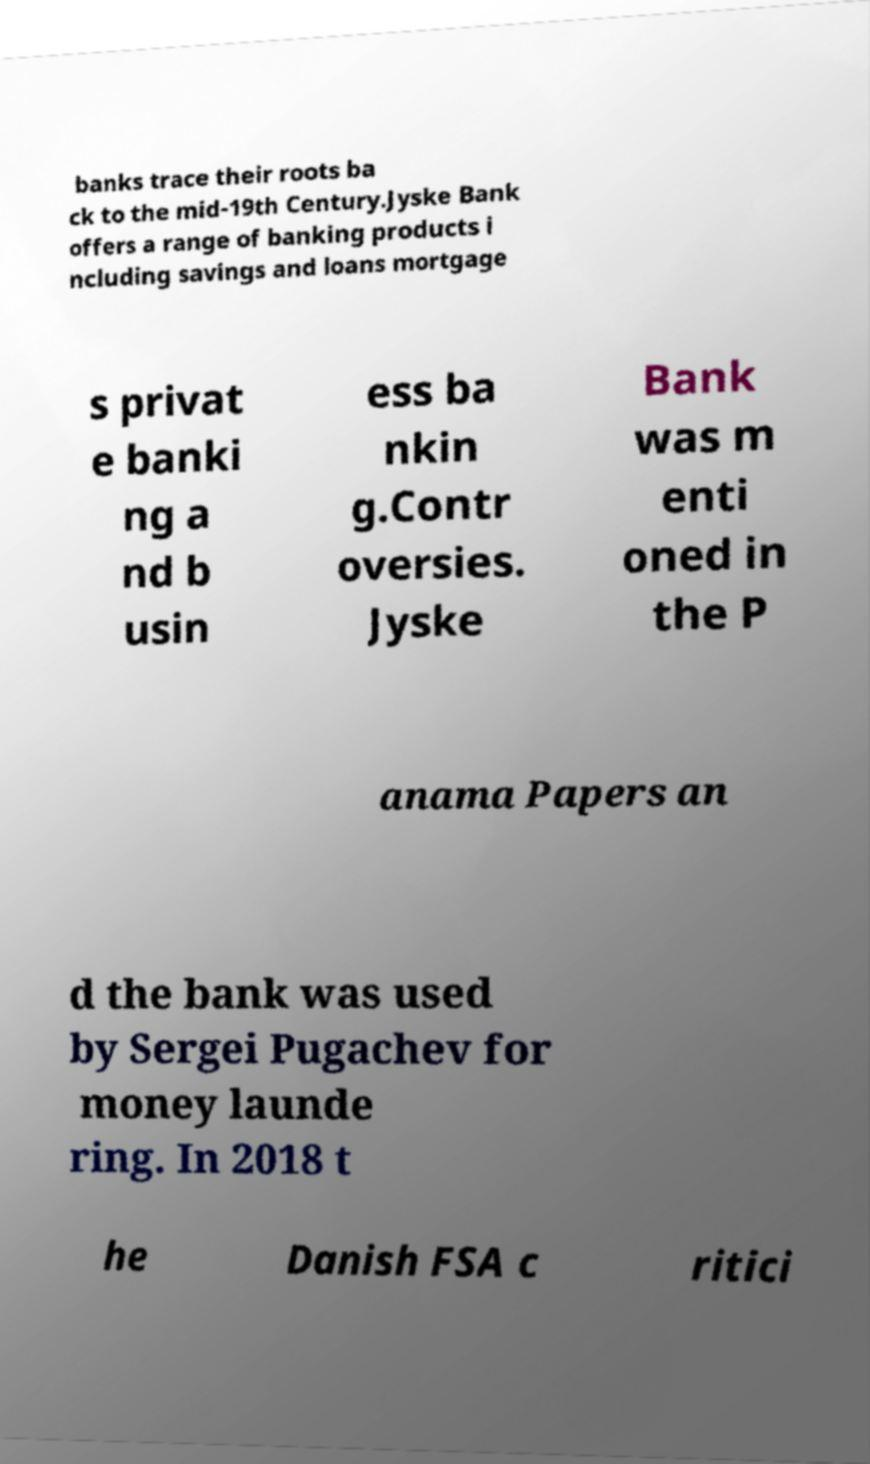Please identify and transcribe the text found in this image. banks trace their roots ba ck to the mid-19th Century.Jyske Bank offers a range of banking products i ncluding savings and loans mortgage s privat e banki ng a nd b usin ess ba nkin g.Contr oversies. Jyske Bank was m enti oned in the P anama Papers an d the bank was used by Sergei Pugachev for money launde ring. In 2018 t he Danish FSA c ritici 